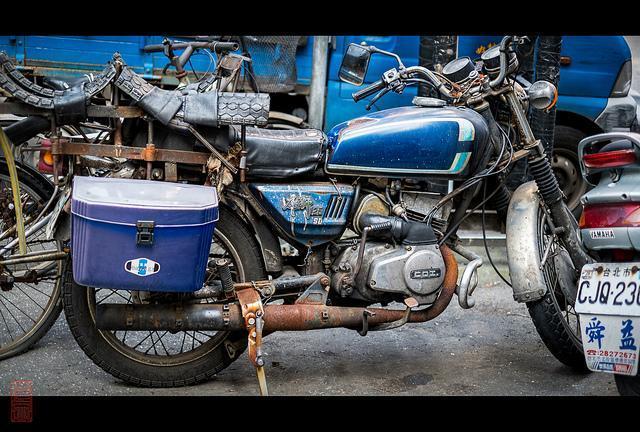How many different shades of blue are on the motorcycle?
Give a very brief answer. 3. How many motorcycles are in the picture?
Give a very brief answer. 2. How many brown cats are there?
Give a very brief answer. 0. 